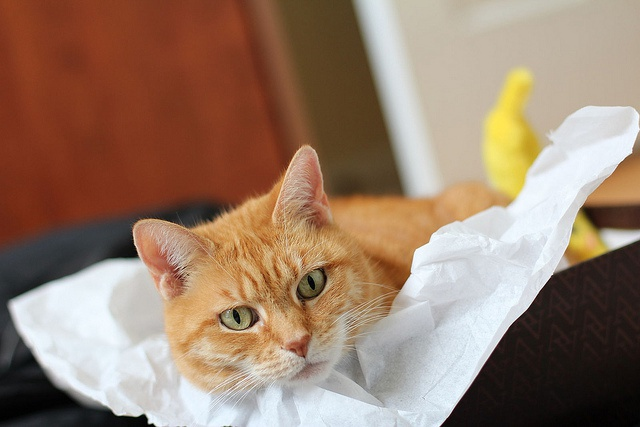Describe the objects in this image and their specific colors. I can see cat in maroon, tan, and brown tones and banana in maroon, khaki, tan, and gold tones in this image. 